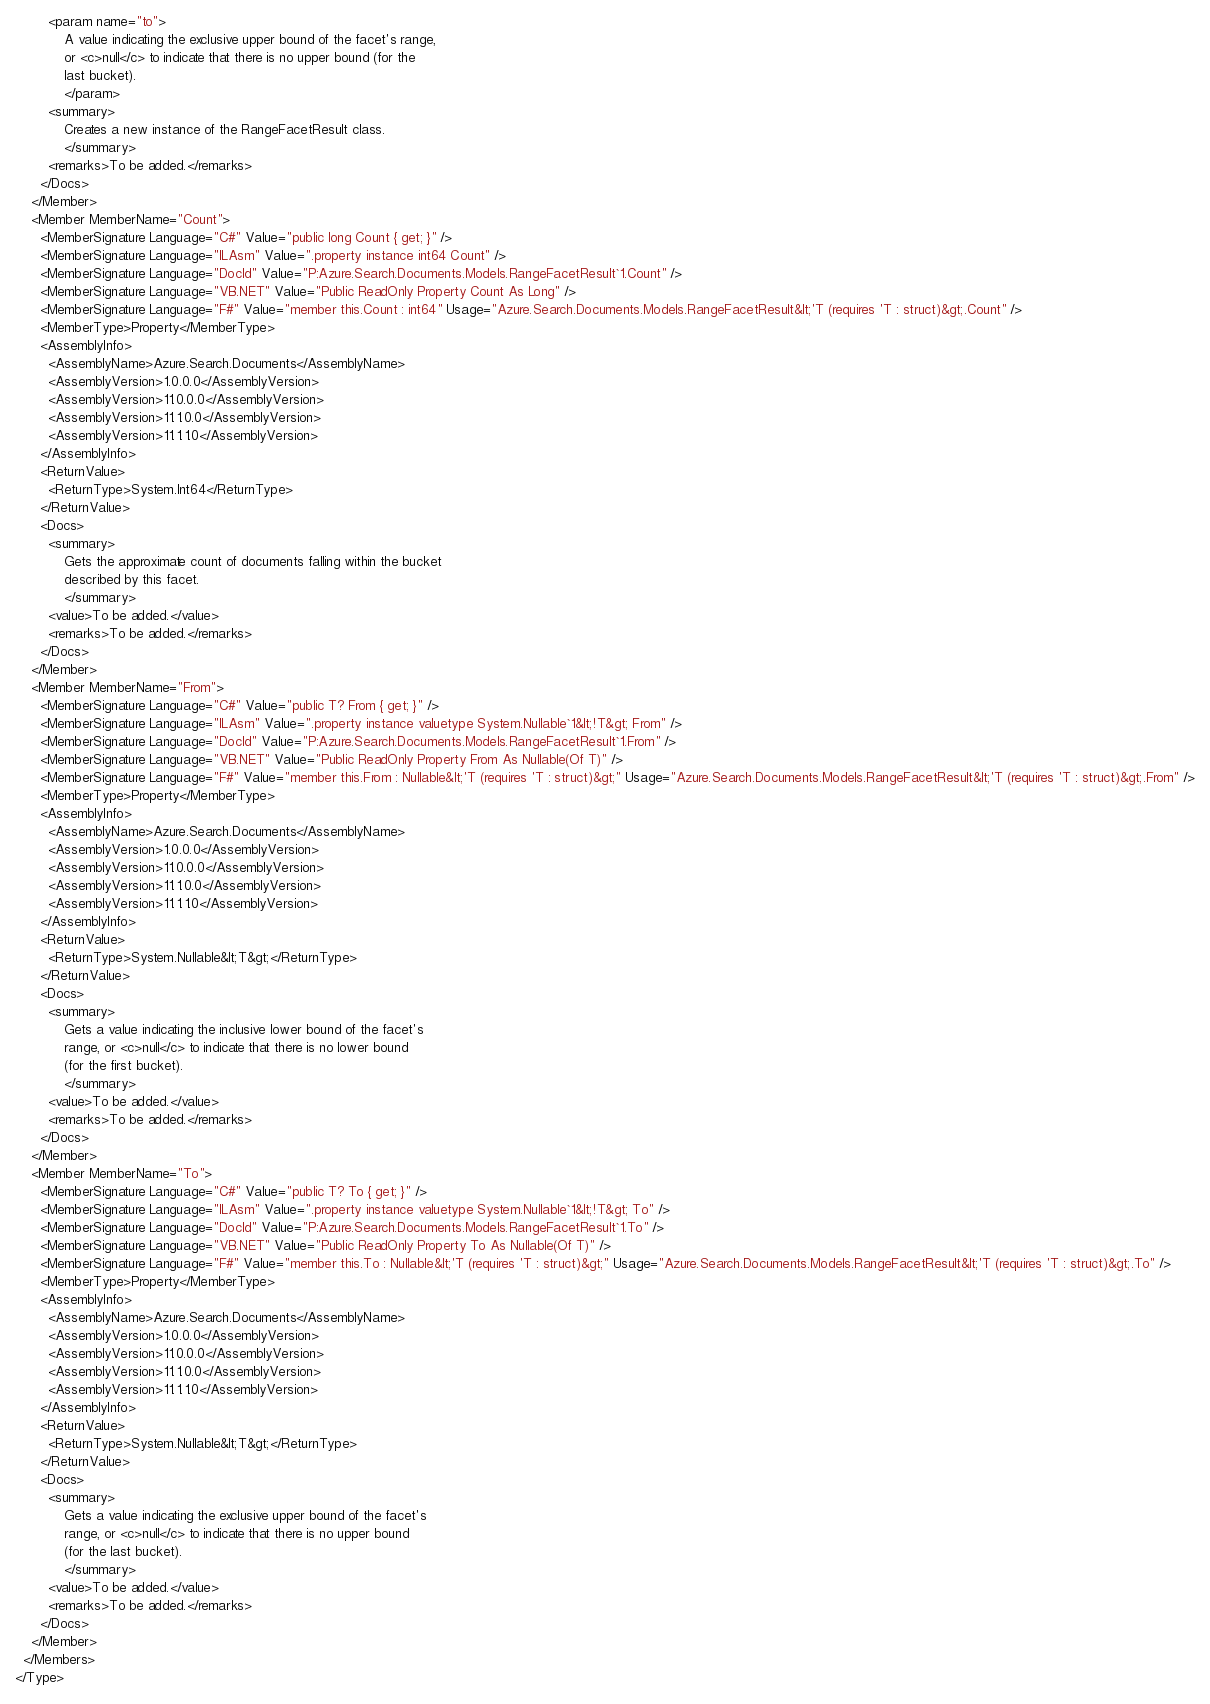Convert code to text. <code><loc_0><loc_0><loc_500><loc_500><_XML_>        <param name="to">
            A value indicating the exclusive upper bound of the facet's range,
            or <c>null</c> to indicate that there is no upper bound (for the
            last bucket).
            </param>
        <summary>
            Creates a new instance of the RangeFacetResult class.
            </summary>
        <remarks>To be added.</remarks>
      </Docs>
    </Member>
    <Member MemberName="Count">
      <MemberSignature Language="C#" Value="public long Count { get; }" />
      <MemberSignature Language="ILAsm" Value=".property instance int64 Count" />
      <MemberSignature Language="DocId" Value="P:Azure.Search.Documents.Models.RangeFacetResult`1.Count" />
      <MemberSignature Language="VB.NET" Value="Public ReadOnly Property Count As Long" />
      <MemberSignature Language="F#" Value="member this.Count : int64" Usage="Azure.Search.Documents.Models.RangeFacetResult&lt;'T (requires 'T : struct)&gt;.Count" />
      <MemberType>Property</MemberType>
      <AssemblyInfo>
        <AssemblyName>Azure.Search.Documents</AssemblyName>
        <AssemblyVersion>1.0.0.0</AssemblyVersion>
        <AssemblyVersion>11.0.0.0</AssemblyVersion>
        <AssemblyVersion>11.1.0.0</AssemblyVersion>
        <AssemblyVersion>11.1.1.0</AssemblyVersion>
      </AssemblyInfo>
      <ReturnValue>
        <ReturnType>System.Int64</ReturnType>
      </ReturnValue>
      <Docs>
        <summary>
            Gets the approximate count of documents falling within the bucket
            described by this facet.
            </summary>
        <value>To be added.</value>
        <remarks>To be added.</remarks>
      </Docs>
    </Member>
    <Member MemberName="From">
      <MemberSignature Language="C#" Value="public T? From { get; }" />
      <MemberSignature Language="ILAsm" Value=".property instance valuetype System.Nullable`1&lt;!T&gt; From" />
      <MemberSignature Language="DocId" Value="P:Azure.Search.Documents.Models.RangeFacetResult`1.From" />
      <MemberSignature Language="VB.NET" Value="Public ReadOnly Property From As Nullable(Of T)" />
      <MemberSignature Language="F#" Value="member this.From : Nullable&lt;'T (requires 'T : struct)&gt;" Usage="Azure.Search.Documents.Models.RangeFacetResult&lt;'T (requires 'T : struct)&gt;.From" />
      <MemberType>Property</MemberType>
      <AssemblyInfo>
        <AssemblyName>Azure.Search.Documents</AssemblyName>
        <AssemblyVersion>1.0.0.0</AssemblyVersion>
        <AssemblyVersion>11.0.0.0</AssemblyVersion>
        <AssemblyVersion>11.1.0.0</AssemblyVersion>
        <AssemblyVersion>11.1.1.0</AssemblyVersion>
      </AssemblyInfo>
      <ReturnValue>
        <ReturnType>System.Nullable&lt;T&gt;</ReturnType>
      </ReturnValue>
      <Docs>
        <summary>
            Gets a value indicating the inclusive lower bound of the facet's
            range, or <c>null</c> to indicate that there is no lower bound
            (for the first bucket).
            </summary>
        <value>To be added.</value>
        <remarks>To be added.</remarks>
      </Docs>
    </Member>
    <Member MemberName="To">
      <MemberSignature Language="C#" Value="public T? To { get; }" />
      <MemberSignature Language="ILAsm" Value=".property instance valuetype System.Nullable`1&lt;!T&gt; To" />
      <MemberSignature Language="DocId" Value="P:Azure.Search.Documents.Models.RangeFacetResult`1.To" />
      <MemberSignature Language="VB.NET" Value="Public ReadOnly Property To As Nullable(Of T)" />
      <MemberSignature Language="F#" Value="member this.To : Nullable&lt;'T (requires 'T : struct)&gt;" Usage="Azure.Search.Documents.Models.RangeFacetResult&lt;'T (requires 'T : struct)&gt;.To" />
      <MemberType>Property</MemberType>
      <AssemblyInfo>
        <AssemblyName>Azure.Search.Documents</AssemblyName>
        <AssemblyVersion>1.0.0.0</AssemblyVersion>
        <AssemblyVersion>11.0.0.0</AssemblyVersion>
        <AssemblyVersion>11.1.0.0</AssemblyVersion>
        <AssemblyVersion>11.1.1.0</AssemblyVersion>
      </AssemblyInfo>
      <ReturnValue>
        <ReturnType>System.Nullable&lt;T&gt;</ReturnType>
      </ReturnValue>
      <Docs>
        <summary>
            Gets a value indicating the exclusive upper bound of the facet's
            range, or <c>null</c> to indicate that there is no upper bound
            (for the last bucket).
            </summary>
        <value>To be added.</value>
        <remarks>To be added.</remarks>
      </Docs>
    </Member>
  </Members>
</Type>
</code> 